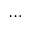<formula> <loc_0><loc_0><loc_500><loc_500>\dots</formula> 